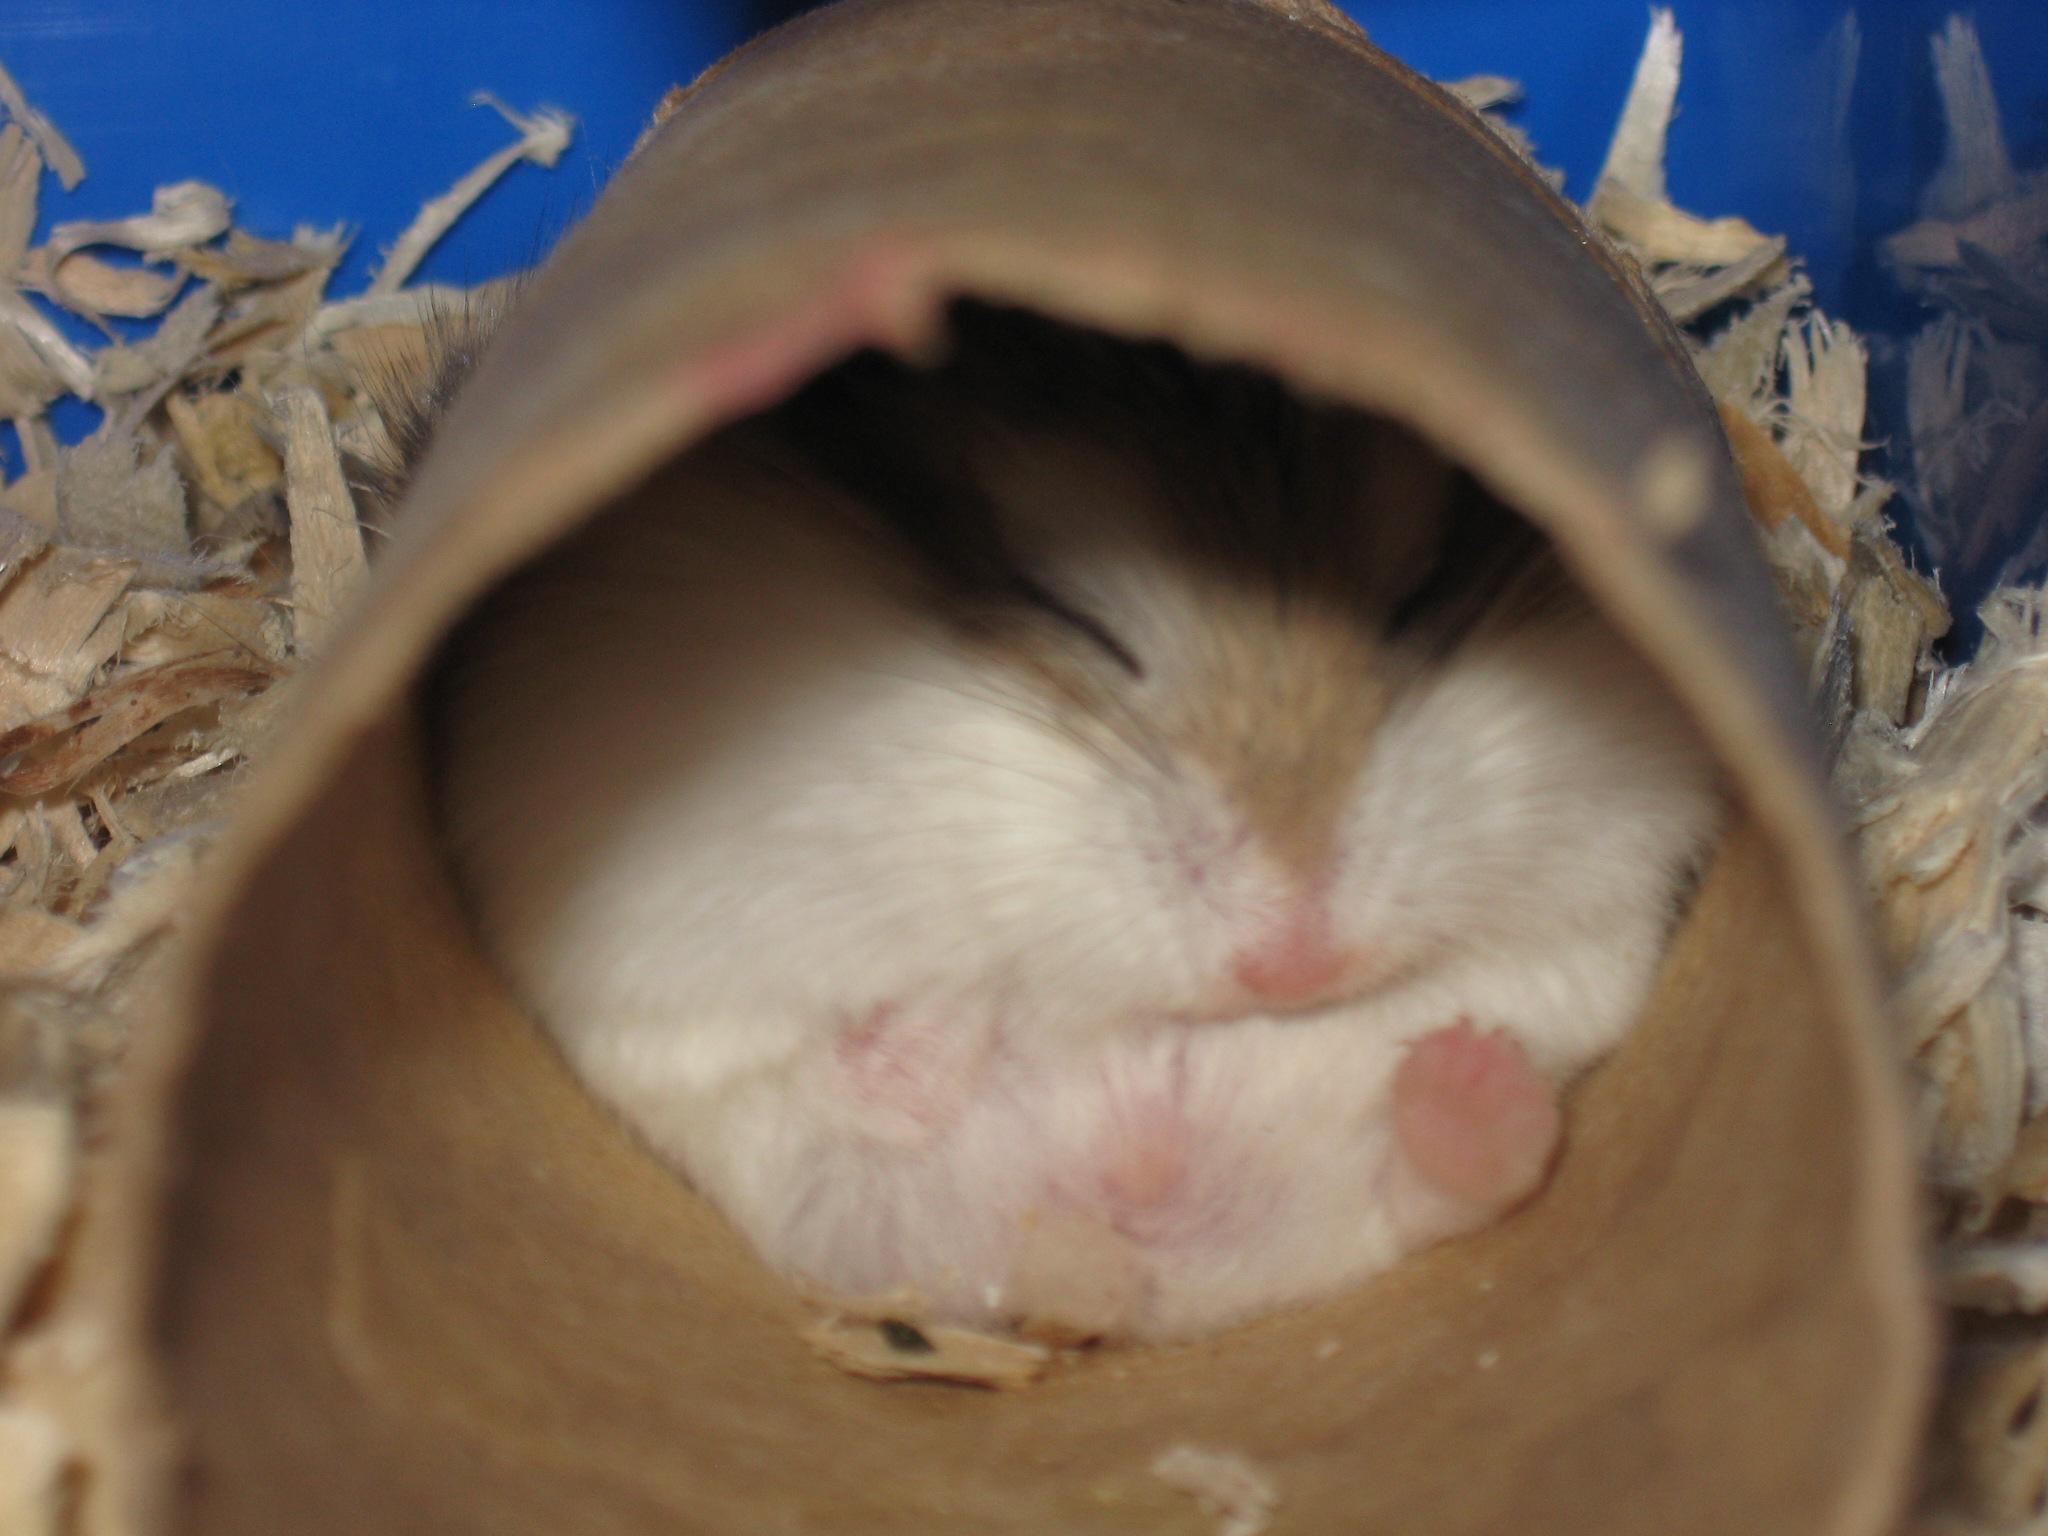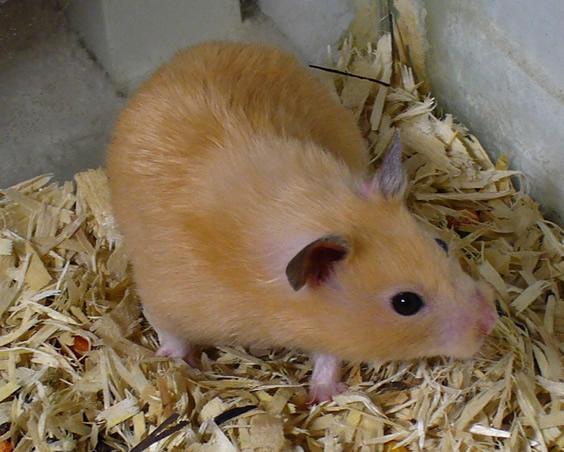The first image is the image on the left, the second image is the image on the right. For the images shown, is this caption "There is a tiny mammal in a human hand." true? Answer yes or no. No. The first image is the image on the left, the second image is the image on the right. Assess this claim about the two images: "An image shows the white-furred belly of a hamster on its back with all four paws in the air.". Correct or not? Answer yes or no. No. 